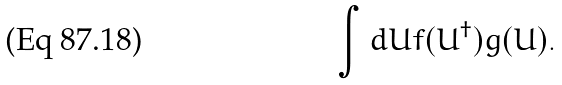Convert formula to latex. <formula><loc_0><loc_0><loc_500><loc_500>\int d U f ( U ^ { \dagger } ) g ( U ) .</formula> 